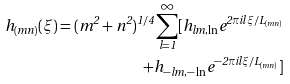<formula> <loc_0><loc_0><loc_500><loc_500>h _ { ( m n ) } ( \xi ) = ( { m ^ { 2 } + n ^ { 2 } } ) ^ { 1 / 4 } \sum _ { l = 1 } ^ { \infty } [ h _ { l m , \ln } e ^ { 2 \pi i l \xi / L _ { ( m n ) } } \\ + h _ { - l m , - \ln } e ^ { - 2 \pi i l \xi / L _ { ( m n ) } } ]</formula> 